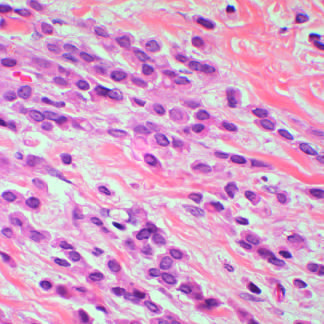re normal marrow cells composed of noncohesive tumor cells that invade as linear cords of cells and induce little stromal response?
Answer the question using a single word or phrase. No 